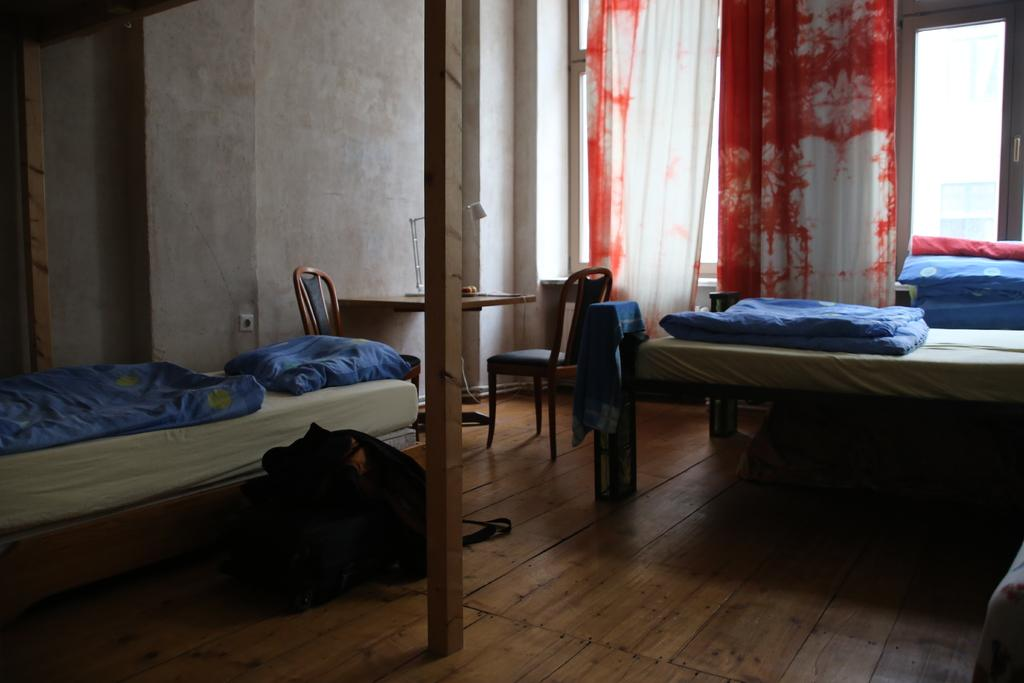What type of space is shown in the image? The image depicts a room. What furniture is present in the room? There is a bed with a blanket, a backpack, a table, and a chair in the room. What can be seen on the windows in the room? Windows with curtains hanging are visible in the room. What color is the tail of the dog in the room? There is no dog present in the image, so there is no tail to describe. 